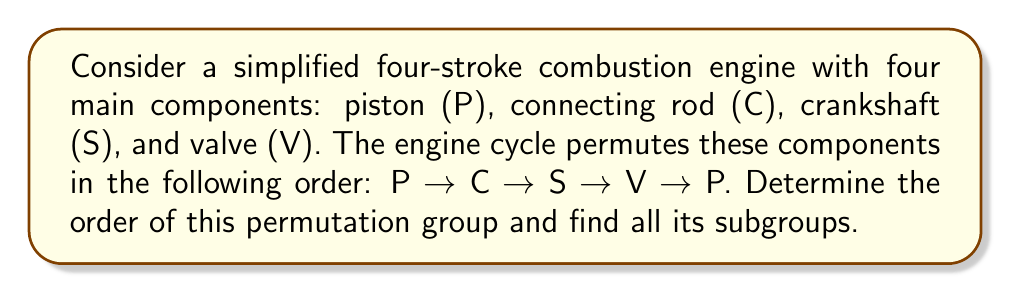What is the answer to this math problem? Let's approach this step-by-step:

1) First, we need to represent the permutation in cycle notation:
   $$(P C S V)$$

2) To find the order of this permutation, we count the number of elements in the cycle. Here, we have 4 elements, so the order is 4.

3) The order of the permutation group is equal to the least common multiple (LCM) of the lengths of its disjoint cycles. In this case, we have only one cycle of length 4, so the order of the group is 4.

4) To find all subgroups, we need to consider all possible powers of this permutation:

   Identity: $e = (P)(C)(S)(V)$
   First power: $(P C S V)$
   Second power: $(P C S V)^2 = (P S)(C V)$
   Third power: $(P C S V)^3 = (P V S C)$

5) The subgroups are:
   - $\{e\}$ (trivial subgroup)
   - $\{e, (P C S V), (P S)(C V), (P V S C)\}$ (the entire group)
   - $\{e, (P S)(C V)\}$ (subgroup of order 2)

6) We can verify that these are indeed all the subgroups by checking that they satisfy the closure property and contain the identity element.
Answer: The order of the permutation group is 4. The subgroups are:
1) $\{e\}$
2) $\{e, (P C S V), (P S)(C V), (P V S C)\}$
3) $\{e, (P S)(C V)\}$ 